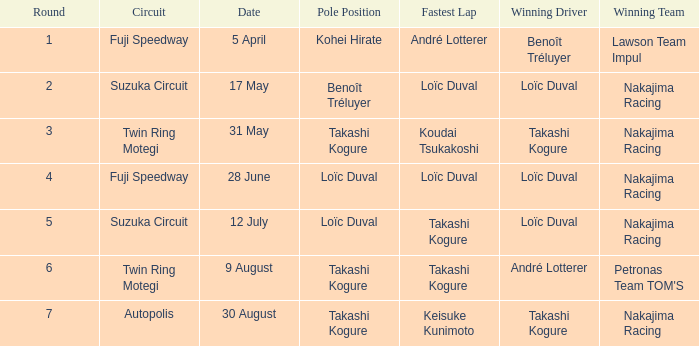Who was the driver for the winning team Lawson Team Impul? Benoît Tréluyer. 